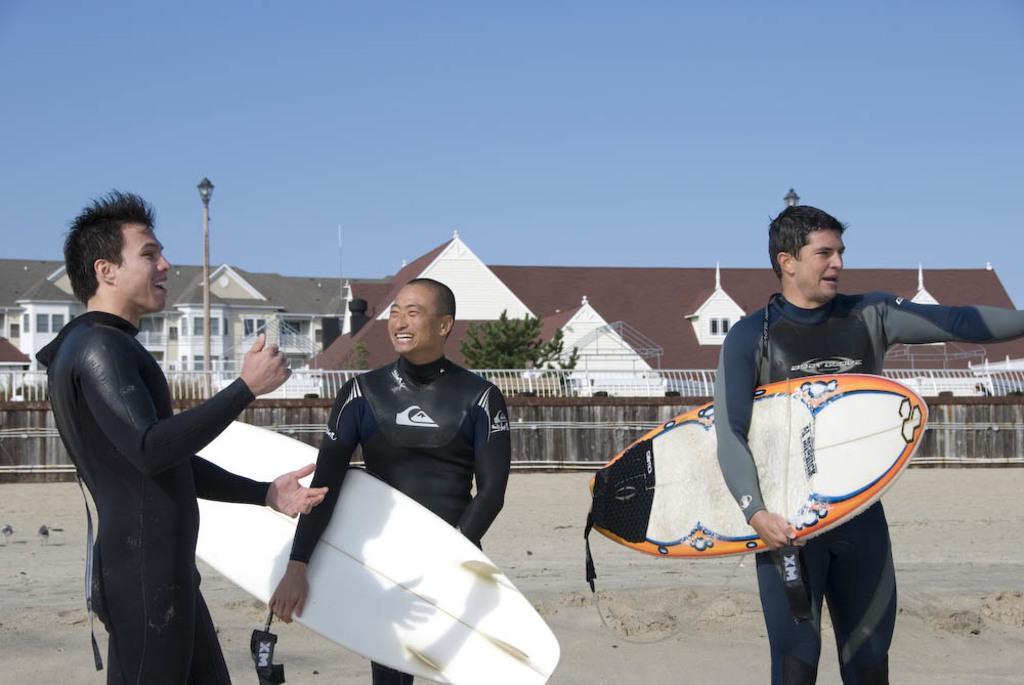Could you give a brief overview of what you see in this image? In this picture we can see three persons standing in the middle. These are the surfboards. On the background there is a tree. And this is the house. Here we can see the sky. 